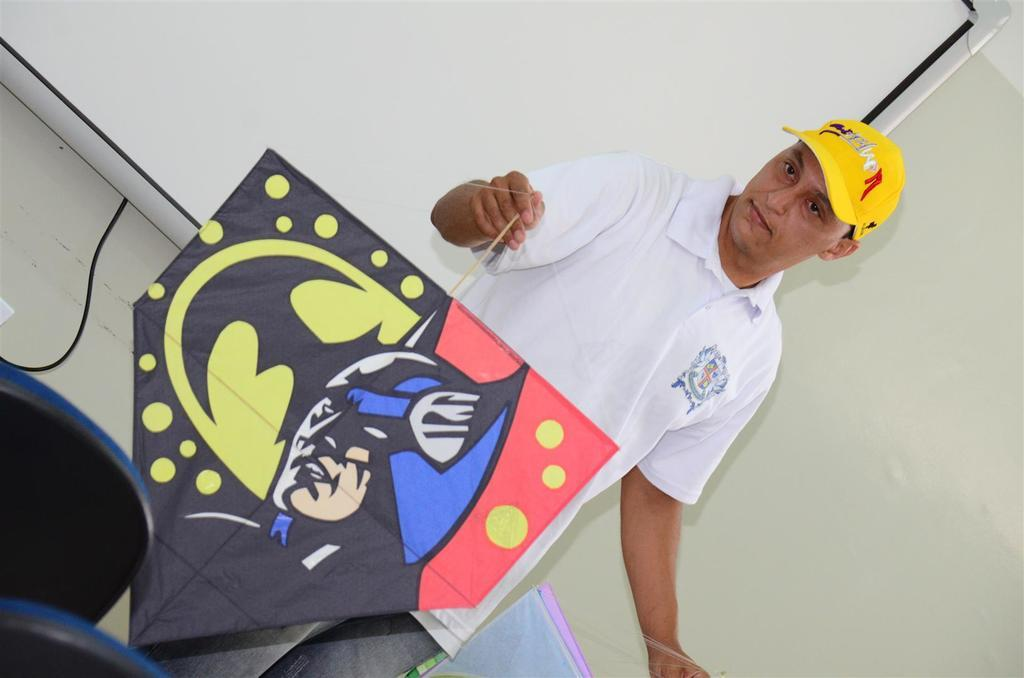What is the person in the image doing? The person is holding objects in the image. What can be seen on the wall in the image? There is a wall with a projector screen in the image. What is the purpose of the wire visible in the image? The wire's purpose is not specified, but it may be related to the projector screen or other equipment. What type of furniture is present in the image? There are chairs in the image. What type of scissors are being used to cut the afternoon in the image? There is no scissors or afternoon present in the image. Is there a stage visible in the image? No, there is no stage visible in the image. 